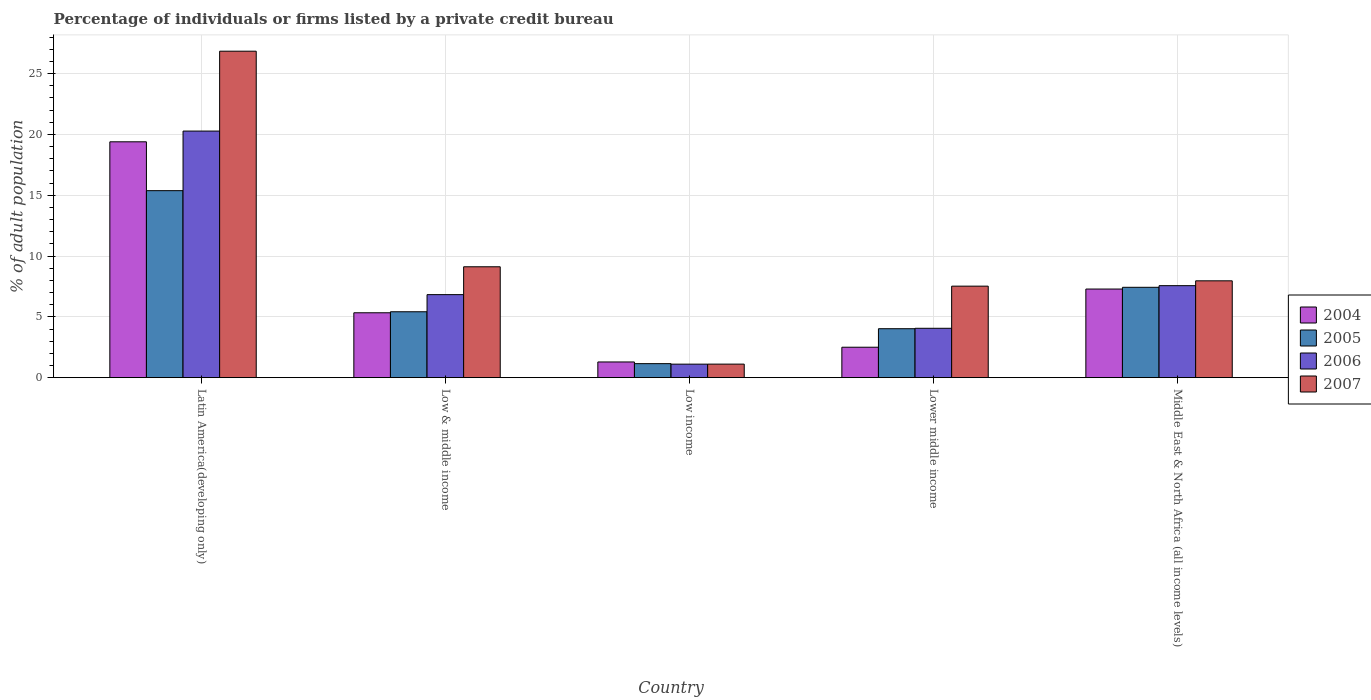How many groups of bars are there?
Keep it short and to the point. 5. Are the number of bars on each tick of the X-axis equal?
Ensure brevity in your answer.  Yes. How many bars are there on the 4th tick from the left?
Your response must be concise. 4. How many bars are there on the 5th tick from the right?
Offer a very short reply. 4. What is the label of the 5th group of bars from the left?
Provide a succinct answer. Middle East & North Africa (all income levels). What is the percentage of population listed by a private credit bureau in 2004 in Low & middle income?
Your response must be concise. 5.34. Across all countries, what is the maximum percentage of population listed by a private credit bureau in 2006?
Your response must be concise. 20.28. Across all countries, what is the minimum percentage of population listed by a private credit bureau in 2006?
Your answer should be compact. 1.11. In which country was the percentage of population listed by a private credit bureau in 2006 maximum?
Offer a terse response. Latin America(developing only). What is the total percentage of population listed by a private credit bureau in 2006 in the graph?
Give a very brief answer. 39.84. What is the difference between the percentage of population listed by a private credit bureau in 2007 in Latin America(developing only) and that in Middle East & North Africa (all income levels)?
Make the answer very short. 18.88. What is the difference between the percentage of population listed by a private credit bureau in 2007 in Middle East & North Africa (all income levels) and the percentage of population listed by a private credit bureau in 2004 in Lower middle income?
Your response must be concise. 5.46. What is the average percentage of population listed by a private credit bureau in 2004 per country?
Provide a succinct answer. 7.16. What is the difference between the percentage of population listed by a private credit bureau of/in 2007 and percentage of population listed by a private credit bureau of/in 2005 in Middle East & North Africa (all income levels)?
Make the answer very short. 0.53. What is the ratio of the percentage of population listed by a private credit bureau in 2006 in Latin America(developing only) to that in Lower middle income?
Provide a succinct answer. 5. Is the percentage of population listed by a private credit bureau in 2004 in Latin America(developing only) less than that in Lower middle income?
Your answer should be compact. No. Is the difference between the percentage of population listed by a private credit bureau in 2007 in Latin America(developing only) and Lower middle income greater than the difference between the percentage of population listed by a private credit bureau in 2005 in Latin America(developing only) and Lower middle income?
Your answer should be very brief. Yes. What is the difference between the highest and the second highest percentage of population listed by a private credit bureau in 2004?
Make the answer very short. 14.06. What is the difference between the highest and the lowest percentage of population listed by a private credit bureau in 2005?
Your response must be concise. 14.22. What does the 4th bar from the left in Low & middle income represents?
Make the answer very short. 2007. What does the 2nd bar from the right in Lower middle income represents?
Give a very brief answer. 2006. Are all the bars in the graph horizontal?
Offer a very short reply. No. What is the difference between two consecutive major ticks on the Y-axis?
Make the answer very short. 5. Does the graph contain any zero values?
Keep it short and to the point. No. Does the graph contain grids?
Make the answer very short. Yes. Where does the legend appear in the graph?
Provide a short and direct response. Center right. What is the title of the graph?
Provide a short and direct response. Percentage of individuals or firms listed by a private credit bureau. What is the label or title of the Y-axis?
Make the answer very short. % of adult population. What is the % of adult population in 2004 in Latin America(developing only)?
Ensure brevity in your answer.  19.39. What is the % of adult population of 2005 in Latin America(developing only)?
Make the answer very short. 15.38. What is the % of adult population of 2006 in Latin America(developing only)?
Make the answer very short. 20.28. What is the % of adult population in 2007 in Latin America(developing only)?
Your answer should be compact. 26.84. What is the % of adult population in 2004 in Low & middle income?
Your response must be concise. 5.34. What is the % of adult population of 2005 in Low & middle income?
Provide a short and direct response. 5.42. What is the % of adult population in 2006 in Low & middle income?
Give a very brief answer. 6.83. What is the % of adult population of 2007 in Low & middle income?
Your response must be concise. 9.12. What is the % of adult population of 2004 in Low income?
Make the answer very short. 1.29. What is the % of adult population in 2005 in Low income?
Keep it short and to the point. 1.15. What is the % of adult population in 2006 in Low income?
Ensure brevity in your answer.  1.11. What is the % of adult population of 2007 in Low income?
Keep it short and to the point. 1.11. What is the % of adult population of 2004 in Lower middle income?
Your response must be concise. 2.5. What is the % of adult population of 2005 in Lower middle income?
Your answer should be very brief. 4.03. What is the % of adult population in 2006 in Lower middle income?
Ensure brevity in your answer.  4.06. What is the % of adult population of 2007 in Lower middle income?
Your response must be concise. 7.53. What is the % of adult population of 2004 in Middle East & North Africa (all income levels)?
Give a very brief answer. 7.29. What is the % of adult population of 2005 in Middle East & North Africa (all income levels)?
Offer a terse response. 7.43. What is the % of adult population in 2006 in Middle East & North Africa (all income levels)?
Give a very brief answer. 7.56. What is the % of adult population of 2007 in Middle East & North Africa (all income levels)?
Offer a terse response. 7.96. Across all countries, what is the maximum % of adult population of 2004?
Your response must be concise. 19.39. Across all countries, what is the maximum % of adult population in 2005?
Make the answer very short. 15.38. Across all countries, what is the maximum % of adult population in 2006?
Give a very brief answer. 20.28. Across all countries, what is the maximum % of adult population in 2007?
Provide a short and direct response. 26.84. Across all countries, what is the minimum % of adult population of 2004?
Offer a very short reply. 1.29. Across all countries, what is the minimum % of adult population in 2005?
Your response must be concise. 1.15. Across all countries, what is the minimum % of adult population in 2006?
Give a very brief answer. 1.11. Across all countries, what is the minimum % of adult population in 2007?
Provide a succinct answer. 1.11. What is the total % of adult population in 2004 in the graph?
Make the answer very short. 35.81. What is the total % of adult population of 2005 in the graph?
Provide a succinct answer. 33.4. What is the total % of adult population in 2006 in the graph?
Provide a short and direct response. 39.84. What is the total % of adult population of 2007 in the graph?
Ensure brevity in your answer.  52.56. What is the difference between the % of adult population in 2004 in Latin America(developing only) and that in Low & middle income?
Offer a very short reply. 14.06. What is the difference between the % of adult population in 2005 in Latin America(developing only) and that in Low & middle income?
Offer a very short reply. 9.96. What is the difference between the % of adult population in 2006 in Latin America(developing only) and that in Low & middle income?
Ensure brevity in your answer.  13.45. What is the difference between the % of adult population of 2007 in Latin America(developing only) and that in Low & middle income?
Your answer should be very brief. 17.73. What is the difference between the % of adult population in 2004 in Latin America(developing only) and that in Low income?
Your answer should be compact. 18.1. What is the difference between the % of adult population of 2005 in Latin America(developing only) and that in Low income?
Ensure brevity in your answer.  14.22. What is the difference between the % of adult population of 2006 in Latin America(developing only) and that in Low income?
Ensure brevity in your answer.  19.17. What is the difference between the % of adult population in 2007 in Latin America(developing only) and that in Low income?
Make the answer very short. 25.73. What is the difference between the % of adult population in 2004 in Latin America(developing only) and that in Lower middle income?
Make the answer very short. 16.89. What is the difference between the % of adult population of 2005 in Latin America(developing only) and that in Lower middle income?
Your answer should be very brief. 11.35. What is the difference between the % of adult population of 2006 in Latin America(developing only) and that in Lower middle income?
Offer a very short reply. 16.22. What is the difference between the % of adult population of 2007 in Latin America(developing only) and that in Lower middle income?
Keep it short and to the point. 19.32. What is the difference between the % of adult population of 2004 in Latin America(developing only) and that in Middle East & North Africa (all income levels)?
Ensure brevity in your answer.  12.11. What is the difference between the % of adult population of 2005 in Latin America(developing only) and that in Middle East & North Africa (all income levels)?
Your answer should be compact. 7.95. What is the difference between the % of adult population in 2006 in Latin America(developing only) and that in Middle East & North Africa (all income levels)?
Keep it short and to the point. 12.71. What is the difference between the % of adult population in 2007 in Latin America(developing only) and that in Middle East & North Africa (all income levels)?
Offer a terse response. 18.88. What is the difference between the % of adult population in 2004 in Low & middle income and that in Low income?
Ensure brevity in your answer.  4.04. What is the difference between the % of adult population of 2005 in Low & middle income and that in Low income?
Provide a succinct answer. 4.27. What is the difference between the % of adult population of 2006 in Low & middle income and that in Low income?
Your answer should be compact. 5.72. What is the difference between the % of adult population of 2007 in Low & middle income and that in Low income?
Offer a very short reply. 8. What is the difference between the % of adult population in 2004 in Low & middle income and that in Lower middle income?
Ensure brevity in your answer.  2.83. What is the difference between the % of adult population of 2005 in Low & middle income and that in Lower middle income?
Offer a terse response. 1.39. What is the difference between the % of adult population of 2006 in Low & middle income and that in Lower middle income?
Give a very brief answer. 2.77. What is the difference between the % of adult population of 2007 in Low & middle income and that in Lower middle income?
Make the answer very short. 1.59. What is the difference between the % of adult population in 2004 in Low & middle income and that in Middle East & North Africa (all income levels)?
Keep it short and to the point. -1.95. What is the difference between the % of adult population of 2005 in Low & middle income and that in Middle East & North Africa (all income levels)?
Keep it short and to the point. -2.01. What is the difference between the % of adult population in 2006 in Low & middle income and that in Middle East & North Africa (all income levels)?
Provide a succinct answer. -0.74. What is the difference between the % of adult population of 2007 in Low & middle income and that in Middle East & North Africa (all income levels)?
Offer a very short reply. 1.15. What is the difference between the % of adult population of 2004 in Low income and that in Lower middle income?
Give a very brief answer. -1.21. What is the difference between the % of adult population of 2005 in Low income and that in Lower middle income?
Provide a short and direct response. -2.87. What is the difference between the % of adult population in 2006 in Low income and that in Lower middle income?
Offer a very short reply. -2.95. What is the difference between the % of adult population of 2007 in Low income and that in Lower middle income?
Your answer should be very brief. -6.41. What is the difference between the % of adult population in 2004 in Low income and that in Middle East & North Africa (all income levels)?
Offer a very short reply. -6. What is the difference between the % of adult population in 2005 in Low income and that in Middle East & North Africa (all income levels)?
Your response must be concise. -6.28. What is the difference between the % of adult population in 2006 in Low income and that in Middle East & North Africa (all income levels)?
Your response must be concise. -6.45. What is the difference between the % of adult population in 2007 in Low income and that in Middle East & North Africa (all income levels)?
Give a very brief answer. -6.85. What is the difference between the % of adult population of 2004 in Lower middle income and that in Middle East & North Africa (all income levels)?
Offer a terse response. -4.79. What is the difference between the % of adult population of 2005 in Lower middle income and that in Middle East & North Africa (all income levels)?
Provide a short and direct response. -3.4. What is the difference between the % of adult population of 2006 in Lower middle income and that in Middle East & North Africa (all income levels)?
Your response must be concise. -3.51. What is the difference between the % of adult population of 2007 in Lower middle income and that in Middle East & North Africa (all income levels)?
Make the answer very short. -0.44. What is the difference between the % of adult population in 2004 in Latin America(developing only) and the % of adult population in 2005 in Low & middle income?
Your answer should be very brief. 13.97. What is the difference between the % of adult population of 2004 in Latin America(developing only) and the % of adult population of 2006 in Low & middle income?
Your answer should be compact. 12.57. What is the difference between the % of adult population in 2004 in Latin America(developing only) and the % of adult population in 2007 in Low & middle income?
Your answer should be very brief. 10.28. What is the difference between the % of adult population of 2005 in Latin America(developing only) and the % of adult population of 2006 in Low & middle income?
Your response must be concise. 8.55. What is the difference between the % of adult population of 2005 in Latin America(developing only) and the % of adult population of 2007 in Low & middle income?
Provide a short and direct response. 6.26. What is the difference between the % of adult population of 2006 in Latin America(developing only) and the % of adult population of 2007 in Low & middle income?
Ensure brevity in your answer.  11.16. What is the difference between the % of adult population in 2004 in Latin America(developing only) and the % of adult population in 2005 in Low income?
Keep it short and to the point. 18.24. What is the difference between the % of adult population of 2004 in Latin America(developing only) and the % of adult population of 2006 in Low income?
Make the answer very short. 18.28. What is the difference between the % of adult population of 2004 in Latin America(developing only) and the % of adult population of 2007 in Low income?
Offer a very short reply. 18.28. What is the difference between the % of adult population in 2005 in Latin America(developing only) and the % of adult population in 2006 in Low income?
Offer a terse response. 14.27. What is the difference between the % of adult population of 2005 in Latin America(developing only) and the % of adult population of 2007 in Low income?
Provide a short and direct response. 14.26. What is the difference between the % of adult population of 2006 in Latin America(developing only) and the % of adult population of 2007 in Low income?
Provide a succinct answer. 19.16. What is the difference between the % of adult population of 2004 in Latin America(developing only) and the % of adult population of 2005 in Lower middle income?
Your answer should be compact. 15.37. What is the difference between the % of adult population in 2004 in Latin America(developing only) and the % of adult population in 2006 in Lower middle income?
Offer a terse response. 15.33. What is the difference between the % of adult population in 2004 in Latin America(developing only) and the % of adult population in 2007 in Lower middle income?
Your answer should be very brief. 11.87. What is the difference between the % of adult population in 2005 in Latin America(developing only) and the % of adult population in 2006 in Lower middle income?
Ensure brevity in your answer.  11.32. What is the difference between the % of adult population in 2005 in Latin America(developing only) and the % of adult population in 2007 in Lower middle income?
Your answer should be compact. 7.85. What is the difference between the % of adult population of 2006 in Latin America(developing only) and the % of adult population of 2007 in Lower middle income?
Offer a terse response. 12.75. What is the difference between the % of adult population in 2004 in Latin America(developing only) and the % of adult population in 2005 in Middle East & North Africa (all income levels)?
Give a very brief answer. 11.96. What is the difference between the % of adult population in 2004 in Latin America(developing only) and the % of adult population in 2006 in Middle East & North Africa (all income levels)?
Offer a very short reply. 11.83. What is the difference between the % of adult population of 2004 in Latin America(developing only) and the % of adult population of 2007 in Middle East & North Africa (all income levels)?
Offer a terse response. 11.43. What is the difference between the % of adult population in 2005 in Latin America(developing only) and the % of adult population in 2006 in Middle East & North Africa (all income levels)?
Your answer should be very brief. 7.81. What is the difference between the % of adult population of 2005 in Latin America(developing only) and the % of adult population of 2007 in Middle East & North Africa (all income levels)?
Your answer should be very brief. 7.41. What is the difference between the % of adult population of 2006 in Latin America(developing only) and the % of adult population of 2007 in Middle East & North Africa (all income levels)?
Make the answer very short. 12.31. What is the difference between the % of adult population in 2004 in Low & middle income and the % of adult population in 2005 in Low income?
Your response must be concise. 4.18. What is the difference between the % of adult population of 2004 in Low & middle income and the % of adult population of 2006 in Low income?
Keep it short and to the point. 4.22. What is the difference between the % of adult population in 2004 in Low & middle income and the % of adult population in 2007 in Low income?
Offer a very short reply. 4.22. What is the difference between the % of adult population in 2005 in Low & middle income and the % of adult population in 2006 in Low income?
Make the answer very short. 4.31. What is the difference between the % of adult population of 2005 in Low & middle income and the % of adult population of 2007 in Low income?
Make the answer very short. 4.3. What is the difference between the % of adult population of 2006 in Low & middle income and the % of adult population of 2007 in Low income?
Provide a short and direct response. 5.71. What is the difference between the % of adult population of 2004 in Low & middle income and the % of adult population of 2005 in Lower middle income?
Offer a terse response. 1.31. What is the difference between the % of adult population in 2004 in Low & middle income and the % of adult population in 2006 in Lower middle income?
Provide a short and direct response. 1.28. What is the difference between the % of adult population in 2004 in Low & middle income and the % of adult population in 2007 in Lower middle income?
Your answer should be compact. -2.19. What is the difference between the % of adult population in 2005 in Low & middle income and the % of adult population in 2006 in Lower middle income?
Ensure brevity in your answer.  1.36. What is the difference between the % of adult population in 2005 in Low & middle income and the % of adult population in 2007 in Lower middle income?
Offer a terse response. -2.11. What is the difference between the % of adult population of 2006 in Low & middle income and the % of adult population of 2007 in Lower middle income?
Offer a very short reply. -0.7. What is the difference between the % of adult population in 2004 in Low & middle income and the % of adult population in 2005 in Middle East & North Africa (all income levels)?
Keep it short and to the point. -2.09. What is the difference between the % of adult population of 2004 in Low & middle income and the % of adult population of 2006 in Middle East & North Africa (all income levels)?
Ensure brevity in your answer.  -2.23. What is the difference between the % of adult population of 2004 in Low & middle income and the % of adult population of 2007 in Middle East & North Africa (all income levels)?
Your answer should be compact. -2.63. What is the difference between the % of adult population in 2005 in Low & middle income and the % of adult population in 2006 in Middle East & North Africa (all income levels)?
Your response must be concise. -2.15. What is the difference between the % of adult population of 2005 in Low & middle income and the % of adult population of 2007 in Middle East & North Africa (all income levels)?
Your answer should be compact. -2.54. What is the difference between the % of adult population of 2006 in Low & middle income and the % of adult population of 2007 in Middle East & North Africa (all income levels)?
Give a very brief answer. -1.14. What is the difference between the % of adult population of 2004 in Low income and the % of adult population of 2005 in Lower middle income?
Keep it short and to the point. -2.73. What is the difference between the % of adult population in 2004 in Low income and the % of adult population in 2006 in Lower middle income?
Make the answer very short. -2.77. What is the difference between the % of adult population of 2004 in Low income and the % of adult population of 2007 in Lower middle income?
Offer a very short reply. -6.23. What is the difference between the % of adult population in 2005 in Low income and the % of adult population in 2006 in Lower middle income?
Your answer should be compact. -2.91. What is the difference between the % of adult population of 2005 in Low income and the % of adult population of 2007 in Lower middle income?
Offer a terse response. -6.37. What is the difference between the % of adult population of 2006 in Low income and the % of adult population of 2007 in Lower middle income?
Your answer should be compact. -6.41. What is the difference between the % of adult population of 2004 in Low income and the % of adult population of 2005 in Middle East & North Africa (all income levels)?
Offer a very short reply. -6.14. What is the difference between the % of adult population in 2004 in Low income and the % of adult population in 2006 in Middle East & North Africa (all income levels)?
Make the answer very short. -6.27. What is the difference between the % of adult population of 2004 in Low income and the % of adult population of 2007 in Middle East & North Africa (all income levels)?
Keep it short and to the point. -6.67. What is the difference between the % of adult population of 2005 in Low income and the % of adult population of 2006 in Middle East & North Africa (all income levels)?
Ensure brevity in your answer.  -6.41. What is the difference between the % of adult population in 2005 in Low income and the % of adult population in 2007 in Middle East & North Africa (all income levels)?
Offer a terse response. -6.81. What is the difference between the % of adult population of 2006 in Low income and the % of adult population of 2007 in Middle East & North Africa (all income levels)?
Make the answer very short. -6.85. What is the difference between the % of adult population in 2004 in Lower middle income and the % of adult population in 2005 in Middle East & North Africa (all income levels)?
Your answer should be very brief. -4.93. What is the difference between the % of adult population of 2004 in Lower middle income and the % of adult population of 2006 in Middle East & North Africa (all income levels)?
Provide a short and direct response. -5.06. What is the difference between the % of adult population of 2004 in Lower middle income and the % of adult population of 2007 in Middle East & North Africa (all income levels)?
Keep it short and to the point. -5.46. What is the difference between the % of adult population of 2005 in Lower middle income and the % of adult population of 2006 in Middle East & North Africa (all income levels)?
Offer a very short reply. -3.54. What is the difference between the % of adult population in 2005 in Lower middle income and the % of adult population in 2007 in Middle East & North Africa (all income levels)?
Ensure brevity in your answer.  -3.94. What is the difference between the % of adult population of 2006 in Lower middle income and the % of adult population of 2007 in Middle East & North Africa (all income levels)?
Provide a short and direct response. -3.9. What is the average % of adult population in 2004 per country?
Offer a very short reply. 7.16. What is the average % of adult population of 2005 per country?
Ensure brevity in your answer.  6.68. What is the average % of adult population of 2006 per country?
Offer a very short reply. 7.97. What is the average % of adult population in 2007 per country?
Your response must be concise. 10.51. What is the difference between the % of adult population of 2004 and % of adult population of 2005 in Latin America(developing only)?
Offer a terse response. 4.02. What is the difference between the % of adult population of 2004 and % of adult population of 2006 in Latin America(developing only)?
Offer a terse response. -0.88. What is the difference between the % of adult population of 2004 and % of adult population of 2007 in Latin America(developing only)?
Provide a succinct answer. -7.45. What is the difference between the % of adult population in 2005 and % of adult population in 2006 in Latin America(developing only)?
Provide a short and direct response. -4.9. What is the difference between the % of adult population in 2005 and % of adult population in 2007 in Latin America(developing only)?
Offer a very short reply. -11.47. What is the difference between the % of adult population of 2006 and % of adult population of 2007 in Latin America(developing only)?
Your answer should be compact. -6.57. What is the difference between the % of adult population in 2004 and % of adult population in 2005 in Low & middle income?
Your answer should be compact. -0.08. What is the difference between the % of adult population of 2004 and % of adult population of 2006 in Low & middle income?
Offer a very short reply. -1.49. What is the difference between the % of adult population of 2004 and % of adult population of 2007 in Low & middle income?
Give a very brief answer. -3.78. What is the difference between the % of adult population in 2005 and % of adult population in 2006 in Low & middle income?
Keep it short and to the point. -1.41. What is the difference between the % of adult population in 2005 and % of adult population in 2007 in Low & middle income?
Give a very brief answer. -3.7. What is the difference between the % of adult population in 2006 and % of adult population in 2007 in Low & middle income?
Keep it short and to the point. -2.29. What is the difference between the % of adult population of 2004 and % of adult population of 2005 in Low income?
Give a very brief answer. 0.14. What is the difference between the % of adult population of 2004 and % of adult population of 2006 in Low income?
Ensure brevity in your answer.  0.18. What is the difference between the % of adult population of 2004 and % of adult population of 2007 in Low income?
Your answer should be very brief. 0.18. What is the difference between the % of adult population of 2005 and % of adult population of 2006 in Low income?
Ensure brevity in your answer.  0.04. What is the difference between the % of adult population of 2005 and % of adult population of 2007 in Low income?
Give a very brief answer. 0.04. What is the difference between the % of adult population in 2006 and % of adult population in 2007 in Low income?
Your answer should be very brief. -0. What is the difference between the % of adult population in 2004 and % of adult population in 2005 in Lower middle income?
Provide a short and direct response. -1.52. What is the difference between the % of adult population of 2004 and % of adult population of 2006 in Lower middle income?
Offer a terse response. -1.56. What is the difference between the % of adult population in 2004 and % of adult population in 2007 in Lower middle income?
Offer a very short reply. -5.02. What is the difference between the % of adult population in 2005 and % of adult population in 2006 in Lower middle income?
Your response must be concise. -0.03. What is the difference between the % of adult population of 2006 and % of adult population of 2007 in Lower middle income?
Offer a very short reply. -3.47. What is the difference between the % of adult population of 2004 and % of adult population of 2005 in Middle East & North Africa (all income levels)?
Your answer should be compact. -0.14. What is the difference between the % of adult population of 2004 and % of adult population of 2006 in Middle East & North Africa (all income levels)?
Make the answer very short. -0.28. What is the difference between the % of adult population of 2004 and % of adult population of 2007 in Middle East & North Africa (all income levels)?
Your answer should be very brief. -0.68. What is the difference between the % of adult population in 2005 and % of adult population in 2006 in Middle East & North Africa (all income levels)?
Make the answer very short. -0.14. What is the difference between the % of adult population in 2005 and % of adult population in 2007 in Middle East & North Africa (all income levels)?
Provide a succinct answer. -0.53. What is the difference between the % of adult population in 2006 and % of adult population in 2007 in Middle East & North Africa (all income levels)?
Provide a short and direct response. -0.4. What is the ratio of the % of adult population of 2004 in Latin America(developing only) to that in Low & middle income?
Your answer should be compact. 3.63. What is the ratio of the % of adult population in 2005 in Latin America(developing only) to that in Low & middle income?
Provide a short and direct response. 2.84. What is the ratio of the % of adult population of 2006 in Latin America(developing only) to that in Low & middle income?
Offer a terse response. 2.97. What is the ratio of the % of adult population in 2007 in Latin America(developing only) to that in Low & middle income?
Give a very brief answer. 2.94. What is the ratio of the % of adult population in 2004 in Latin America(developing only) to that in Low income?
Your response must be concise. 15.01. What is the ratio of the % of adult population of 2005 in Latin America(developing only) to that in Low income?
Ensure brevity in your answer.  13.35. What is the ratio of the % of adult population in 2006 in Latin America(developing only) to that in Low income?
Your answer should be very brief. 18.26. What is the ratio of the % of adult population of 2007 in Latin America(developing only) to that in Low income?
Keep it short and to the point. 24.09. What is the ratio of the % of adult population in 2004 in Latin America(developing only) to that in Lower middle income?
Offer a very short reply. 7.75. What is the ratio of the % of adult population in 2005 in Latin America(developing only) to that in Lower middle income?
Your answer should be compact. 3.82. What is the ratio of the % of adult population in 2006 in Latin America(developing only) to that in Lower middle income?
Give a very brief answer. 5. What is the ratio of the % of adult population of 2007 in Latin America(developing only) to that in Lower middle income?
Provide a succinct answer. 3.57. What is the ratio of the % of adult population of 2004 in Latin America(developing only) to that in Middle East & North Africa (all income levels)?
Your answer should be very brief. 2.66. What is the ratio of the % of adult population of 2005 in Latin America(developing only) to that in Middle East & North Africa (all income levels)?
Give a very brief answer. 2.07. What is the ratio of the % of adult population of 2006 in Latin America(developing only) to that in Middle East & North Africa (all income levels)?
Your response must be concise. 2.68. What is the ratio of the % of adult population of 2007 in Latin America(developing only) to that in Middle East & North Africa (all income levels)?
Provide a short and direct response. 3.37. What is the ratio of the % of adult population in 2004 in Low & middle income to that in Low income?
Your answer should be very brief. 4.13. What is the ratio of the % of adult population in 2005 in Low & middle income to that in Low income?
Give a very brief answer. 4.7. What is the ratio of the % of adult population in 2006 in Low & middle income to that in Low income?
Provide a short and direct response. 6.15. What is the ratio of the % of adult population of 2007 in Low & middle income to that in Low income?
Your answer should be compact. 8.18. What is the ratio of the % of adult population of 2004 in Low & middle income to that in Lower middle income?
Provide a succinct answer. 2.13. What is the ratio of the % of adult population of 2005 in Low & middle income to that in Lower middle income?
Provide a succinct answer. 1.35. What is the ratio of the % of adult population in 2006 in Low & middle income to that in Lower middle income?
Offer a terse response. 1.68. What is the ratio of the % of adult population of 2007 in Low & middle income to that in Lower middle income?
Provide a succinct answer. 1.21. What is the ratio of the % of adult population of 2004 in Low & middle income to that in Middle East & North Africa (all income levels)?
Ensure brevity in your answer.  0.73. What is the ratio of the % of adult population of 2005 in Low & middle income to that in Middle East & North Africa (all income levels)?
Provide a short and direct response. 0.73. What is the ratio of the % of adult population of 2006 in Low & middle income to that in Middle East & North Africa (all income levels)?
Your response must be concise. 0.9. What is the ratio of the % of adult population in 2007 in Low & middle income to that in Middle East & North Africa (all income levels)?
Your answer should be compact. 1.14. What is the ratio of the % of adult population in 2004 in Low income to that in Lower middle income?
Offer a very short reply. 0.52. What is the ratio of the % of adult population in 2005 in Low income to that in Lower middle income?
Your response must be concise. 0.29. What is the ratio of the % of adult population of 2006 in Low income to that in Lower middle income?
Provide a short and direct response. 0.27. What is the ratio of the % of adult population of 2007 in Low income to that in Lower middle income?
Your response must be concise. 0.15. What is the ratio of the % of adult population of 2004 in Low income to that in Middle East & North Africa (all income levels)?
Your answer should be compact. 0.18. What is the ratio of the % of adult population in 2005 in Low income to that in Middle East & North Africa (all income levels)?
Provide a succinct answer. 0.15. What is the ratio of the % of adult population in 2006 in Low income to that in Middle East & North Africa (all income levels)?
Give a very brief answer. 0.15. What is the ratio of the % of adult population in 2007 in Low income to that in Middle East & North Africa (all income levels)?
Provide a short and direct response. 0.14. What is the ratio of the % of adult population of 2004 in Lower middle income to that in Middle East & North Africa (all income levels)?
Your answer should be compact. 0.34. What is the ratio of the % of adult population of 2005 in Lower middle income to that in Middle East & North Africa (all income levels)?
Give a very brief answer. 0.54. What is the ratio of the % of adult population in 2006 in Lower middle income to that in Middle East & North Africa (all income levels)?
Make the answer very short. 0.54. What is the ratio of the % of adult population of 2007 in Lower middle income to that in Middle East & North Africa (all income levels)?
Offer a very short reply. 0.94. What is the difference between the highest and the second highest % of adult population in 2004?
Your answer should be compact. 12.11. What is the difference between the highest and the second highest % of adult population of 2005?
Ensure brevity in your answer.  7.95. What is the difference between the highest and the second highest % of adult population of 2006?
Make the answer very short. 12.71. What is the difference between the highest and the second highest % of adult population of 2007?
Your answer should be very brief. 17.73. What is the difference between the highest and the lowest % of adult population in 2004?
Keep it short and to the point. 18.1. What is the difference between the highest and the lowest % of adult population of 2005?
Provide a short and direct response. 14.22. What is the difference between the highest and the lowest % of adult population of 2006?
Your answer should be very brief. 19.17. What is the difference between the highest and the lowest % of adult population in 2007?
Give a very brief answer. 25.73. 